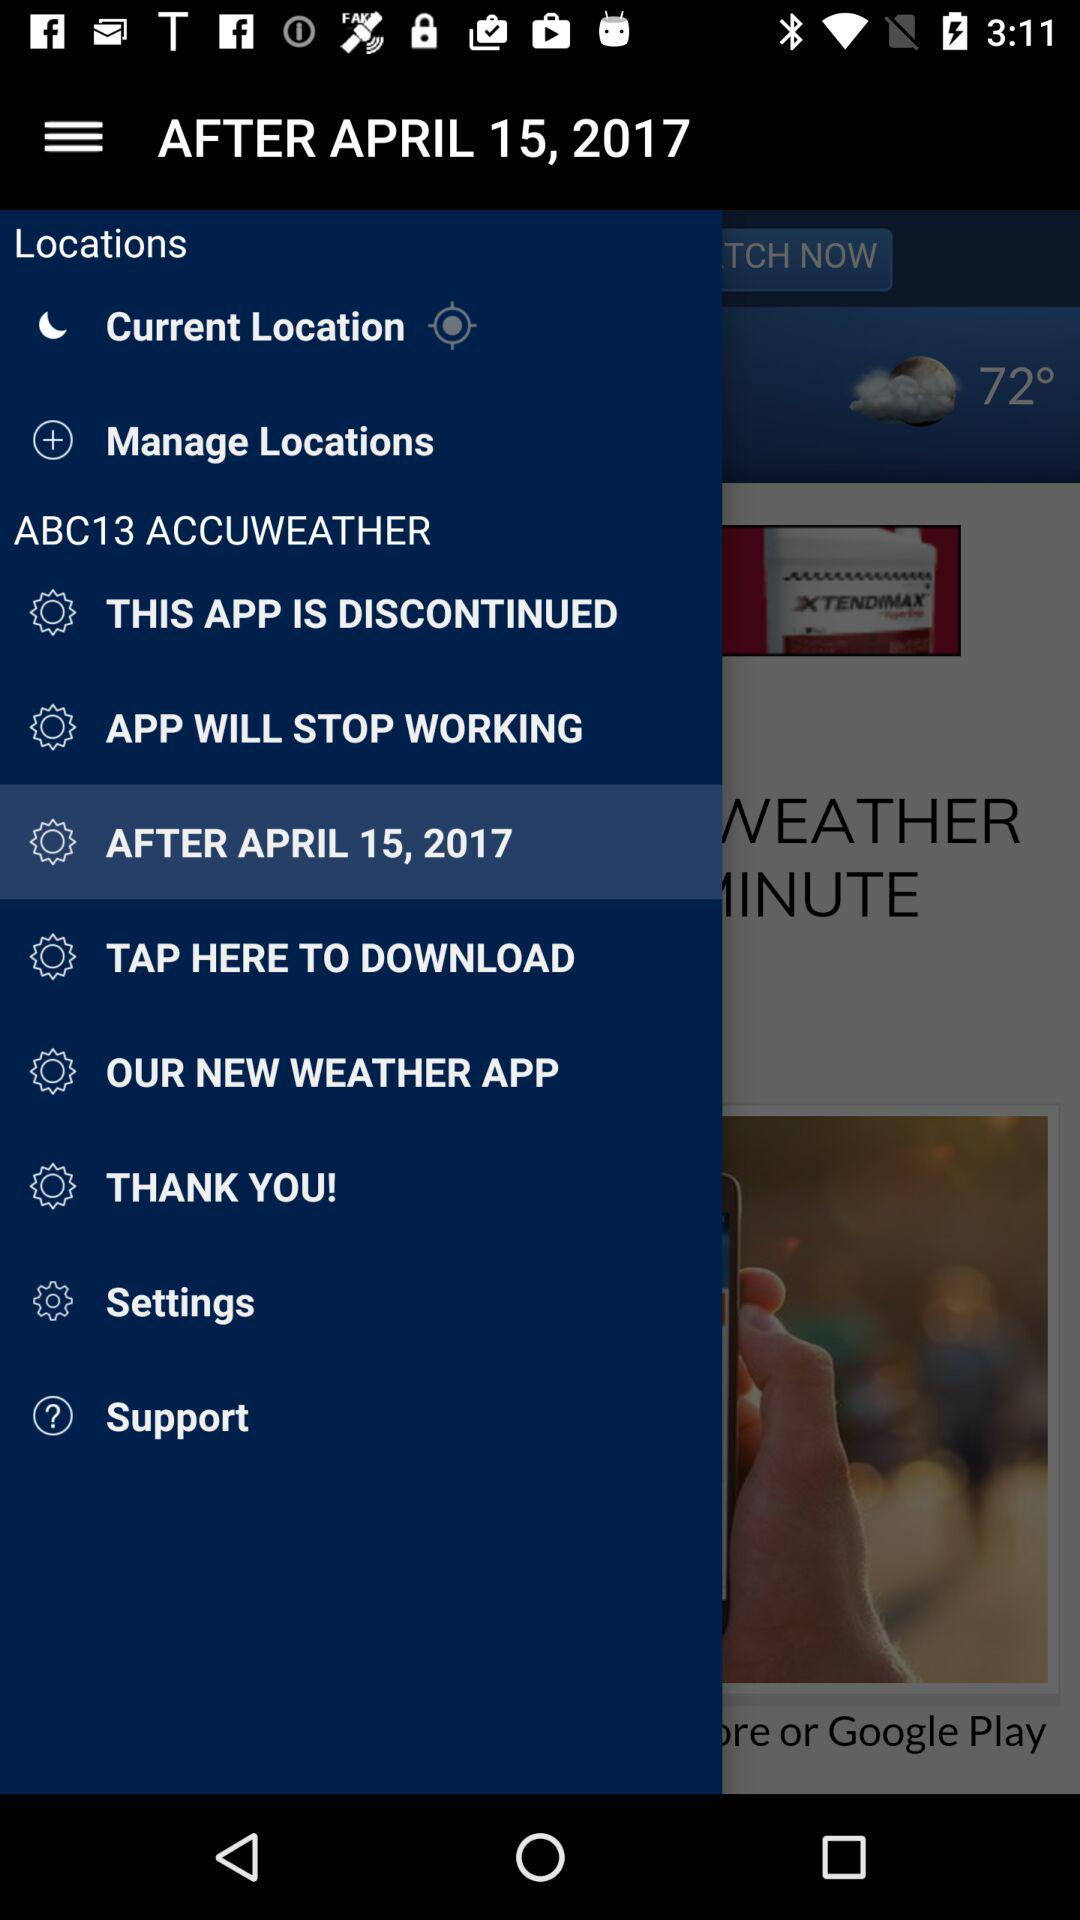What is the temperature right now? The temperature right now is 72°. 